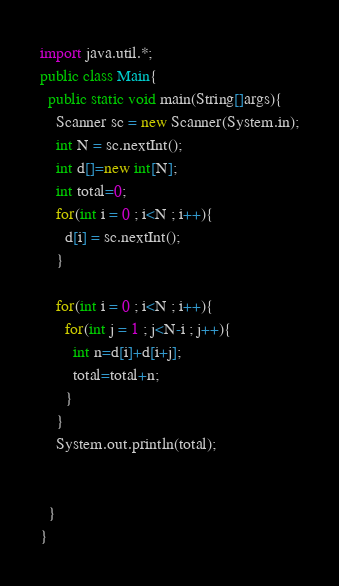<code> <loc_0><loc_0><loc_500><loc_500><_Java_>import java.util.*;
public class Main{
  public static void main(String[]args){
    Scanner sc = new Scanner(System.in);
    int N = sc.nextInt();
    int d[]=new int[N];
    int total=0;
    for(int i = 0 ; i<N ; i++){
      d[i] = sc.nextInt();
    }

    for(int i = 0 ; i<N ; i++){
      for(int j = 1 ; j<N-i ; j++){
        int n=d[i]+d[i+j];
        total=total+n;
      }
    }
    System.out.println(total);


  }
}
</code> 